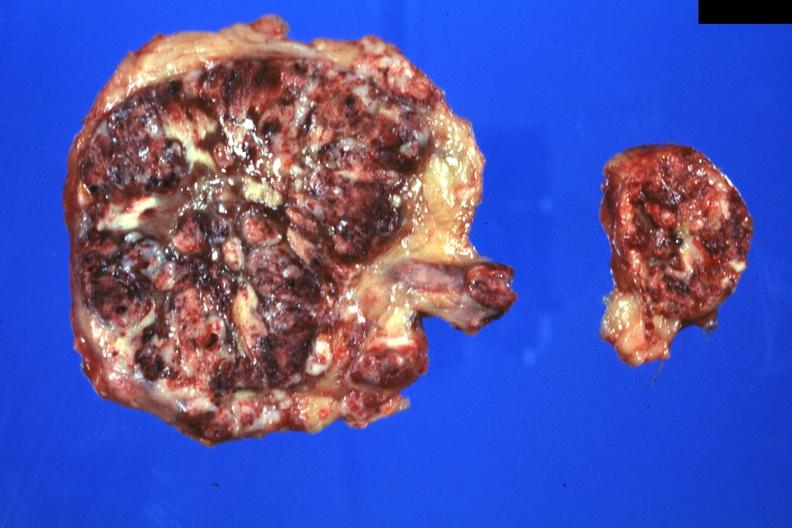s cranial artery present?
Answer the question using a single word or phrase. No 